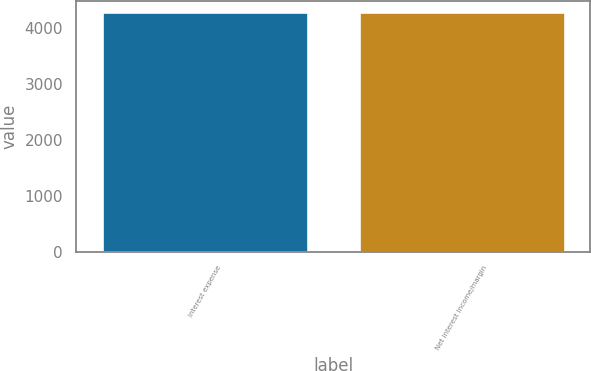<chart> <loc_0><loc_0><loc_500><loc_500><bar_chart><fcel>Interest expense<fcel>Net interest income/margin<nl><fcel>4281<fcel>4281.1<nl></chart> 